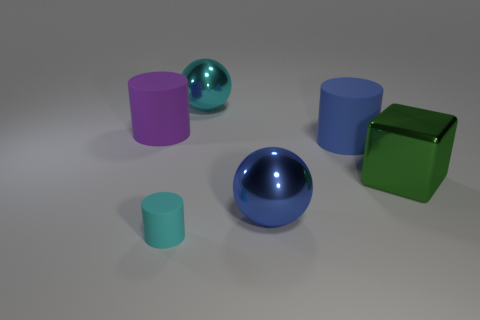There is a rubber cylinder in front of the large blue metallic sphere; what is its size?
Keep it short and to the point. Small. Are there any other things that have the same shape as the green thing?
Keep it short and to the point. No. There is another big thing that is the same shape as the purple object; what color is it?
Offer a terse response. Blue. What is the size of the blue metal object?
Your response must be concise. Large. Is the number of large purple cylinders in front of the small cyan rubber cylinder less than the number of tiny blue cylinders?
Your answer should be compact. No. Does the large blue ball have the same material as the big ball that is behind the blue shiny sphere?
Offer a very short reply. Yes. There is a big cylinder that is right of the large rubber cylinder that is left of the cyan ball; is there a block that is behind it?
Make the answer very short. No. Is there anything else that has the same size as the cyan matte cylinder?
Your answer should be very brief. No. What color is the other large cylinder that is made of the same material as the purple cylinder?
Offer a terse response. Blue. There is a thing that is in front of the big blue matte cylinder and left of the blue sphere; what is its size?
Give a very brief answer. Small. 